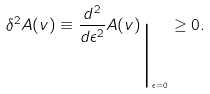Convert formula to latex. <formula><loc_0><loc_0><loc_500><loc_500>\delta ^ { 2 } A ( v ) \equiv \frac { d ^ { 2 } } { d \epsilon ^ { 2 } } A ( v ) _ { \Big | _ { \epsilon = 0 } } \geq 0 .</formula> 